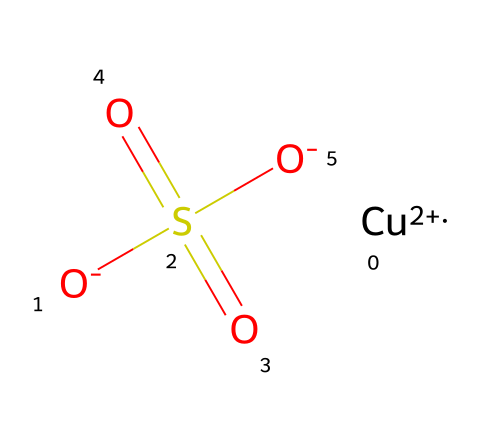What is the molecular formula of this chemical? The chemical is represented in the SMILES format, which encodes its structure. Analyzing the SMILES, we see that it contains one copper atom, and the contribution of the sulfur and oxygen atoms leads us to the molecular formula: CuSO4.
Answer: CuSO4 How many oxygen atoms are present in the compound? The SMILES structure shows that there are four oxygen atoms: two are involved in the sulfate group (S(=O)(=O)) and the two O- ions. Counting gives us a total of four oxygen atoms.
Answer: 4 What is the charge of the copper ion in this structure? The notation [Cu+2] indicates that the copper ion has a +2 charge, which is important for the compound's overall charge balance.
Answer: +2 What role does the sulfate group play in this chemical structure? The sulfate group (S(=O)(=O)[O-]) is a polyatomic ion that contributes to the solubility and stability of the compound in solution, while also participating in reactions that can create patina.
Answer: solubility How does this chemical influence the aging of set pieces? This chemical can react with surfaces in various materials to produce a layer of copper carbonate or other copper compounds, contributing to the visual effects of aging and patina.
Answer: patina formation What type of bonding is predominant in this compound? The compound consists primarily of ionic and covalent bonds, especially seen with the copper ion having ionic interactions with the sulfate group while maintaining the covalent bonds within the sulfate itself.
Answer: ionic and covalent 